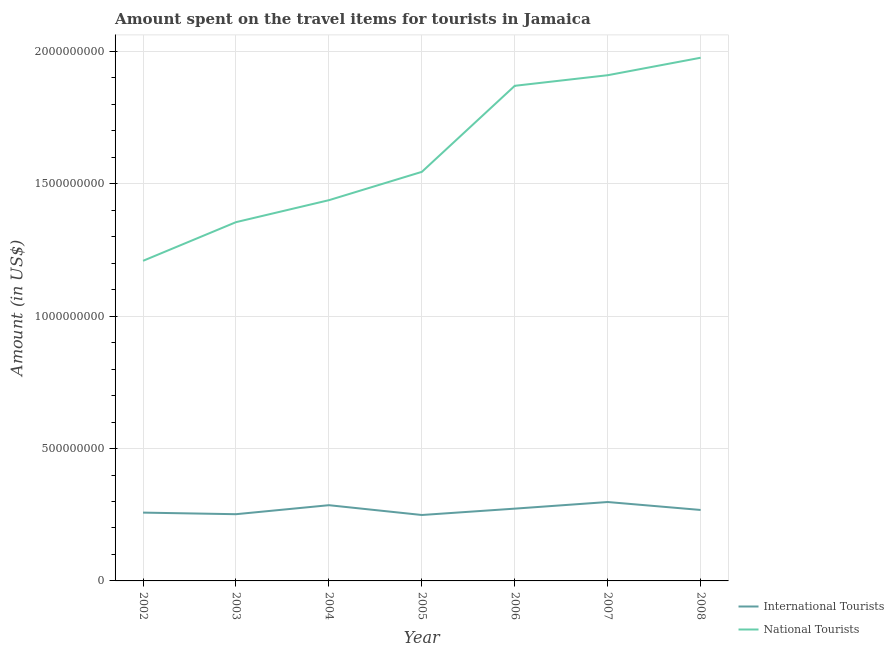Does the line corresponding to amount spent on travel items of international tourists intersect with the line corresponding to amount spent on travel items of national tourists?
Offer a terse response. No. Is the number of lines equal to the number of legend labels?
Give a very brief answer. Yes. What is the amount spent on travel items of international tourists in 2004?
Give a very brief answer. 2.86e+08. Across all years, what is the maximum amount spent on travel items of national tourists?
Provide a short and direct response. 1.98e+09. Across all years, what is the minimum amount spent on travel items of international tourists?
Keep it short and to the point. 2.49e+08. In which year was the amount spent on travel items of international tourists minimum?
Provide a short and direct response. 2005. What is the total amount spent on travel items of international tourists in the graph?
Give a very brief answer. 1.88e+09. What is the difference between the amount spent on travel items of international tourists in 2003 and that in 2006?
Offer a very short reply. -2.10e+07. What is the difference between the amount spent on travel items of international tourists in 2002 and the amount spent on travel items of national tourists in 2008?
Offer a very short reply. -1.72e+09. What is the average amount spent on travel items of national tourists per year?
Keep it short and to the point. 1.61e+09. In the year 2003, what is the difference between the amount spent on travel items of international tourists and amount spent on travel items of national tourists?
Provide a short and direct response. -1.10e+09. In how many years, is the amount spent on travel items of national tourists greater than 600000000 US$?
Your response must be concise. 7. What is the ratio of the amount spent on travel items of international tourists in 2002 to that in 2005?
Offer a very short reply. 1.04. What is the difference between the highest and the second highest amount spent on travel items of national tourists?
Ensure brevity in your answer.  6.60e+07. What is the difference between the highest and the lowest amount spent on travel items of national tourists?
Give a very brief answer. 7.67e+08. In how many years, is the amount spent on travel items of national tourists greater than the average amount spent on travel items of national tourists taken over all years?
Offer a very short reply. 3. Is the amount spent on travel items of international tourists strictly greater than the amount spent on travel items of national tourists over the years?
Your answer should be very brief. No. Is the amount spent on travel items of national tourists strictly less than the amount spent on travel items of international tourists over the years?
Provide a succinct answer. No. How many years are there in the graph?
Keep it short and to the point. 7. Does the graph contain any zero values?
Make the answer very short. No. Does the graph contain grids?
Keep it short and to the point. Yes. Where does the legend appear in the graph?
Provide a short and direct response. Bottom right. How many legend labels are there?
Your answer should be very brief. 2. How are the legend labels stacked?
Your response must be concise. Vertical. What is the title of the graph?
Offer a terse response. Amount spent on the travel items for tourists in Jamaica. Does "constant 2005 US$" appear as one of the legend labels in the graph?
Provide a short and direct response. No. What is the Amount (in US$) of International Tourists in 2002?
Your response must be concise. 2.58e+08. What is the Amount (in US$) in National Tourists in 2002?
Your answer should be compact. 1.21e+09. What is the Amount (in US$) in International Tourists in 2003?
Keep it short and to the point. 2.52e+08. What is the Amount (in US$) of National Tourists in 2003?
Offer a terse response. 1.36e+09. What is the Amount (in US$) in International Tourists in 2004?
Make the answer very short. 2.86e+08. What is the Amount (in US$) of National Tourists in 2004?
Offer a terse response. 1.44e+09. What is the Amount (in US$) in International Tourists in 2005?
Offer a terse response. 2.49e+08. What is the Amount (in US$) of National Tourists in 2005?
Your answer should be compact. 1.54e+09. What is the Amount (in US$) of International Tourists in 2006?
Provide a succinct answer. 2.73e+08. What is the Amount (in US$) in National Tourists in 2006?
Keep it short and to the point. 1.87e+09. What is the Amount (in US$) in International Tourists in 2007?
Ensure brevity in your answer.  2.98e+08. What is the Amount (in US$) in National Tourists in 2007?
Your answer should be very brief. 1.91e+09. What is the Amount (in US$) in International Tourists in 2008?
Give a very brief answer. 2.68e+08. What is the Amount (in US$) in National Tourists in 2008?
Your answer should be very brief. 1.98e+09. Across all years, what is the maximum Amount (in US$) in International Tourists?
Your response must be concise. 2.98e+08. Across all years, what is the maximum Amount (in US$) in National Tourists?
Make the answer very short. 1.98e+09. Across all years, what is the minimum Amount (in US$) in International Tourists?
Offer a terse response. 2.49e+08. Across all years, what is the minimum Amount (in US$) of National Tourists?
Give a very brief answer. 1.21e+09. What is the total Amount (in US$) of International Tourists in the graph?
Ensure brevity in your answer.  1.88e+09. What is the total Amount (in US$) of National Tourists in the graph?
Your response must be concise. 1.13e+1. What is the difference between the Amount (in US$) in National Tourists in 2002 and that in 2003?
Give a very brief answer. -1.46e+08. What is the difference between the Amount (in US$) of International Tourists in 2002 and that in 2004?
Your answer should be compact. -2.80e+07. What is the difference between the Amount (in US$) of National Tourists in 2002 and that in 2004?
Provide a succinct answer. -2.29e+08. What is the difference between the Amount (in US$) in International Tourists in 2002 and that in 2005?
Your answer should be compact. 9.00e+06. What is the difference between the Amount (in US$) of National Tourists in 2002 and that in 2005?
Give a very brief answer. -3.36e+08. What is the difference between the Amount (in US$) in International Tourists in 2002 and that in 2006?
Provide a succinct answer. -1.50e+07. What is the difference between the Amount (in US$) in National Tourists in 2002 and that in 2006?
Give a very brief answer. -6.61e+08. What is the difference between the Amount (in US$) of International Tourists in 2002 and that in 2007?
Your response must be concise. -4.00e+07. What is the difference between the Amount (in US$) of National Tourists in 2002 and that in 2007?
Provide a succinct answer. -7.01e+08. What is the difference between the Amount (in US$) of International Tourists in 2002 and that in 2008?
Keep it short and to the point. -1.00e+07. What is the difference between the Amount (in US$) of National Tourists in 2002 and that in 2008?
Ensure brevity in your answer.  -7.67e+08. What is the difference between the Amount (in US$) of International Tourists in 2003 and that in 2004?
Your response must be concise. -3.40e+07. What is the difference between the Amount (in US$) of National Tourists in 2003 and that in 2004?
Offer a very short reply. -8.30e+07. What is the difference between the Amount (in US$) of National Tourists in 2003 and that in 2005?
Offer a very short reply. -1.90e+08. What is the difference between the Amount (in US$) in International Tourists in 2003 and that in 2006?
Make the answer very short. -2.10e+07. What is the difference between the Amount (in US$) in National Tourists in 2003 and that in 2006?
Keep it short and to the point. -5.15e+08. What is the difference between the Amount (in US$) of International Tourists in 2003 and that in 2007?
Give a very brief answer. -4.60e+07. What is the difference between the Amount (in US$) in National Tourists in 2003 and that in 2007?
Give a very brief answer. -5.55e+08. What is the difference between the Amount (in US$) of International Tourists in 2003 and that in 2008?
Ensure brevity in your answer.  -1.60e+07. What is the difference between the Amount (in US$) of National Tourists in 2003 and that in 2008?
Offer a terse response. -6.21e+08. What is the difference between the Amount (in US$) of International Tourists in 2004 and that in 2005?
Give a very brief answer. 3.70e+07. What is the difference between the Amount (in US$) in National Tourists in 2004 and that in 2005?
Ensure brevity in your answer.  -1.07e+08. What is the difference between the Amount (in US$) of International Tourists in 2004 and that in 2006?
Ensure brevity in your answer.  1.30e+07. What is the difference between the Amount (in US$) of National Tourists in 2004 and that in 2006?
Keep it short and to the point. -4.32e+08. What is the difference between the Amount (in US$) in International Tourists in 2004 and that in 2007?
Provide a succinct answer. -1.20e+07. What is the difference between the Amount (in US$) of National Tourists in 2004 and that in 2007?
Your answer should be compact. -4.72e+08. What is the difference between the Amount (in US$) in International Tourists in 2004 and that in 2008?
Keep it short and to the point. 1.80e+07. What is the difference between the Amount (in US$) in National Tourists in 2004 and that in 2008?
Offer a terse response. -5.38e+08. What is the difference between the Amount (in US$) of International Tourists in 2005 and that in 2006?
Your response must be concise. -2.40e+07. What is the difference between the Amount (in US$) in National Tourists in 2005 and that in 2006?
Keep it short and to the point. -3.25e+08. What is the difference between the Amount (in US$) in International Tourists in 2005 and that in 2007?
Offer a terse response. -4.90e+07. What is the difference between the Amount (in US$) of National Tourists in 2005 and that in 2007?
Offer a terse response. -3.65e+08. What is the difference between the Amount (in US$) of International Tourists in 2005 and that in 2008?
Provide a short and direct response. -1.90e+07. What is the difference between the Amount (in US$) of National Tourists in 2005 and that in 2008?
Offer a terse response. -4.31e+08. What is the difference between the Amount (in US$) of International Tourists in 2006 and that in 2007?
Make the answer very short. -2.50e+07. What is the difference between the Amount (in US$) in National Tourists in 2006 and that in 2007?
Offer a very short reply. -4.00e+07. What is the difference between the Amount (in US$) in National Tourists in 2006 and that in 2008?
Your response must be concise. -1.06e+08. What is the difference between the Amount (in US$) in International Tourists in 2007 and that in 2008?
Keep it short and to the point. 3.00e+07. What is the difference between the Amount (in US$) of National Tourists in 2007 and that in 2008?
Your answer should be very brief. -6.60e+07. What is the difference between the Amount (in US$) in International Tourists in 2002 and the Amount (in US$) in National Tourists in 2003?
Provide a short and direct response. -1.10e+09. What is the difference between the Amount (in US$) in International Tourists in 2002 and the Amount (in US$) in National Tourists in 2004?
Make the answer very short. -1.18e+09. What is the difference between the Amount (in US$) in International Tourists in 2002 and the Amount (in US$) in National Tourists in 2005?
Offer a terse response. -1.29e+09. What is the difference between the Amount (in US$) of International Tourists in 2002 and the Amount (in US$) of National Tourists in 2006?
Keep it short and to the point. -1.61e+09. What is the difference between the Amount (in US$) of International Tourists in 2002 and the Amount (in US$) of National Tourists in 2007?
Ensure brevity in your answer.  -1.65e+09. What is the difference between the Amount (in US$) of International Tourists in 2002 and the Amount (in US$) of National Tourists in 2008?
Offer a very short reply. -1.72e+09. What is the difference between the Amount (in US$) in International Tourists in 2003 and the Amount (in US$) in National Tourists in 2004?
Offer a very short reply. -1.19e+09. What is the difference between the Amount (in US$) in International Tourists in 2003 and the Amount (in US$) in National Tourists in 2005?
Ensure brevity in your answer.  -1.29e+09. What is the difference between the Amount (in US$) of International Tourists in 2003 and the Amount (in US$) of National Tourists in 2006?
Keep it short and to the point. -1.62e+09. What is the difference between the Amount (in US$) of International Tourists in 2003 and the Amount (in US$) of National Tourists in 2007?
Provide a succinct answer. -1.66e+09. What is the difference between the Amount (in US$) in International Tourists in 2003 and the Amount (in US$) in National Tourists in 2008?
Provide a succinct answer. -1.72e+09. What is the difference between the Amount (in US$) of International Tourists in 2004 and the Amount (in US$) of National Tourists in 2005?
Give a very brief answer. -1.26e+09. What is the difference between the Amount (in US$) of International Tourists in 2004 and the Amount (in US$) of National Tourists in 2006?
Ensure brevity in your answer.  -1.58e+09. What is the difference between the Amount (in US$) in International Tourists in 2004 and the Amount (in US$) in National Tourists in 2007?
Provide a short and direct response. -1.62e+09. What is the difference between the Amount (in US$) in International Tourists in 2004 and the Amount (in US$) in National Tourists in 2008?
Offer a very short reply. -1.69e+09. What is the difference between the Amount (in US$) of International Tourists in 2005 and the Amount (in US$) of National Tourists in 2006?
Provide a short and direct response. -1.62e+09. What is the difference between the Amount (in US$) of International Tourists in 2005 and the Amount (in US$) of National Tourists in 2007?
Your answer should be compact. -1.66e+09. What is the difference between the Amount (in US$) of International Tourists in 2005 and the Amount (in US$) of National Tourists in 2008?
Your response must be concise. -1.73e+09. What is the difference between the Amount (in US$) in International Tourists in 2006 and the Amount (in US$) in National Tourists in 2007?
Ensure brevity in your answer.  -1.64e+09. What is the difference between the Amount (in US$) in International Tourists in 2006 and the Amount (in US$) in National Tourists in 2008?
Offer a very short reply. -1.70e+09. What is the difference between the Amount (in US$) in International Tourists in 2007 and the Amount (in US$) in National Tourists in 2008?
Ensure brevity in your answer.  -1.68e+09. What is the average Amount (in US$) in International Tourists per year?
Offer a very short reply. 2.69e+08. What is the average Amount (in US$) of National Tourists per year?
Ensure brevity in your answer.  1.61e+09. In the year 2002, what is the difference between the Amount (in US$) in International Tourists and Amount (in US$) in National Tourists?
Make the answer very short. -9.51e+08. In the year 2003, what is the difference between the Amount (in US$) of International Tourists and Amount (in US$) of National Tourists?
Provide a succinct answer. -1.10e+09. In the year 2004, what is the difference between the Amount (in US$) in International Tourists and Amount (in US$) in National Tourists?
Give a very brief answer. -1.15e+09. In the year 2005, what is the difference between the Amount (in US$) of International Tourists and Amount (in US$) of National Tourists?
Your response must be concise. -1.30e+09. In the year 2006, what is the difference between the Amount (in US$) in International Tourists and Amount (in US$) in National Tourists?
Keep it short and to the point. -1.60e+09. In the year 2007, what is the difference between the Amount (in US$) of International Tourists and Amount (in US$) of National Tourists?
Give a very brief answer. -1.61e+09. In the year 2008, what is the difference between the Amount (in US$) of International Tourists and Amount (in US$) of National Tourists?
Offer a very short reply. -1.71e+09. What is the ratio of the Amount (in US$) of International Tourists in 2002 to that in 2003?
Offer a very short reply. 1.02. What is the ratio of the Amount (in US$) of National Tourists in 2002 to that in 2003?
Ensure brevity in your answer.  0.89. What is the ratio of the Amount (in US$) in International Tourists in 2002 to that in 2004?
Your answer should be compact. 0.9. What is the ratio of the Amount (in US$) in National Tourists in 2002 to that in 2004?
Your response must be concise. 0.84. What is the ratio of the Amount (in US$) of International Tourists in 2002 to that in 2005?
Your answer should be very brief. 1.04. What is the ratio of the Amount (in US$) in National Tourists in 2002 to that in 2005?
Keep it short and to the point. 0.78. What is the ratio of the Amount (in US$) in International Tourists in 2002 to that in 2006?
Keep it short and to the point. 0.95. What is the ratio of the Amount (in US$) in National Tourists in 2002 to that in 2006?
Your answer should be very brief. 0.65. What is the ratio of the Amount (in US$) in International Tourists in 2002 to that in 2007?
Your answer should be very brief. 0.87. What is the ratio of the Amount (in US$) in National Tourists in 2002 to that in 2007?
Give a very brief answer. 0.63. What is the ratio of the Amount (in US$) of International Tourists in 2002 to that in 2008?
Your answer should be compact. 0.96. What is the ratio of the Amount (in US$) in National Tourists in 2002 to that in 2008?
Provide a short and direct response. 0.61. What is the ratio of the Amount (in US$) of International Tourists in 2003 to that in 2004?
Your answer should be very brief. 0.88. What is the ratio of the Amount (in US$) of National Tourists in 2003 to that in 2004?
Your answer should be compact. 0.94. What is the ratio of the Amount (in US$) in National Tourists in 2003 to that in 2005?
Make the answer very short. 0.88. What is the ratio of the Amount (in US$) in International Tourists in 2003 to that in 2006?
Your answer should be very brief. 0.92. What is the ratio of the Amount (in US$) of National Tourists in 2003 to that in 2006?
Offer a very short reply. 0.72. What is the ratio of the Amount (in US$) of International Tourists in 2003 to that in 2007?
Your response must be concise. 0.85. What is the ratio of the Amount (in US$) of National Tourists in 2003 to that in 2007?
Your answer should be very brief. 0.71. What is the ratio of the Amount (in US$) in International Tourists in 2003 to that in 2008?
Offer a very short reply. 0.94. What is the ratio of the Amount (in US$) in National Tourists in 2003 to that in 2008?
Give a very brief answer. 0.69. What is the ratio of the Amount (in US$) in International Tourists in 2004 to that in 2005?
Offer a very short reply. 1.15. What is the ratio of the Amount (in US$) in National Tourists in 2004 to that in 2005?
Make the answer very short. 0.93. What is the ratio of the Amount (in US$) in International Tourists in 2004 to that in 2006?
Offer a terse response. 1.05. What is the ratio of the Amount (in US$) of National Tourists in 2004 to that in 2006?
Your answer should be compact. 0.77. What is the ratio of the Amount (in US$) in International Tourists in 2004 to that in 2007?
Your answer should be very brief. 0.96. What is the ratio of the Amount (in US$) of National Tourists in 2004 to that in 2007?
Give a very brief answer. 0.75. What is the ratio of the Amount (in US$) in International Tourists in 2004 to that in 2008?
Provide a succinct answer. 1.07. What is the ratio of the Amount (in US$) of National Tourists in 2004 to that in 2008?
Make the answer very short. 0.73. What is the ratio of the Amount (in US$) of International Tourists in 2005 to that in 2006?
Your response must be concise. 0.91. What is the ratio of the Amount (in US$) in National Tourists in 2005 to that in 2006?
Keep it short and to the point. 0.83. What is the ratio of the Amount (in US$) in International Tourists in 2005 to that in 2007?
Offer a terse response. 0.84. What is the ratio of the Amount (in US$) of National Tourists in 2005 to that in 2007?
Your response must be concise. 0.81. What is the ratio of the Amount (in US$) of International Tourists in 2005 to that in 2008?
Your answer should be very brief. 0.93. What is the ratio of the Amount (in US$) in National Tourists in 2005 to that in 2008?
Provide a short and direct response. 0.78. What is the ratio of the Amount (in US$) in International Tourists in 2006 to that in 2007?
Your answer should be compact. 0.92. What is the ratio of the Amount (in US$) in National Tourists in 2006 to that in 2007?
Your answer should be very brief. 0.98. What is the ratio of the Amount (in US$) of International Tourists in 2006 to that in 2008?
Provide a short and direct response. 1.02. What is the ratio of the Amount (in US$) of National Tourists in 2006 to that in 2008?
Make the answer very short. 0.95. What is the ratio of the Amount (in US$) in International Tourists in 2007 to that in 2008?
Make the answer very short. 1.11. What is the ratio of the Amount (in US$) of National Tourists in 2007 to that in 2008?
Offer a very short reply. 0.97. What is the difference between the highest and the second highest Amount (in US$) of International Tourists?
Offer a terse response. 1.20e+07. What is the difference between the highest and the second highest Amount (in US$) in National Tourists?
Give a very brief answer. 6.60e+07. What is the difference between the highest and the lowest Amount (in US$) in International Tourists?
Keep it short and to the point. 4.90e+07. What is the difference between the highest and the lowest Amount (in US$) in National Tourists?
Provide a succinct answer. 7.67e+08. 